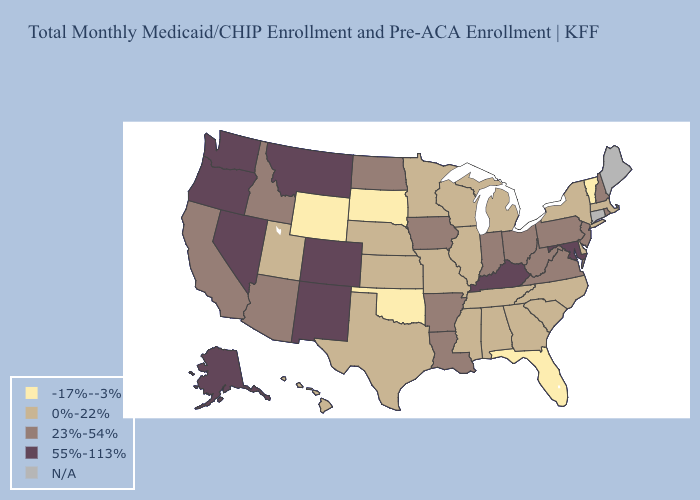Which states hav the highest value in the Northeast?
Give a very brief answer. New Hampshire, New Jersey, Pennsylvania, Rhode Island. What is the lowest value in the USA?
Keep it brief. -17%--3%. Which states hav the highest value in the South?
Answer briefly. Kentucky, Maryland. Which states have the lowest value in the MidWest?
Answer briefly. South Dakota. Does Vermont have the lowest value in the Northeast?
Concise answer only. Yes. Which states hav the highest value in the West?
Short answer required. Alaska, Colorado, Montana, Nevada, New Mexico, Oregon, Washington. Which states have the lowest value in the MidWest?
Be succinct. South Dakota. What is the lowest value in the USA?
Give a very brief answer. -17%--3%. Which states have the highest value in the USA?
Quick response, please. Alaska, Colorado, Kentucky, Maryland, Montana, Nevada, New Mexico, Oregon, Washington. Name the states that have a value in the range N/A?
Quick response, please. Connecticut, Maine. What is the lowest value in the USA?
Write a very short answer. -17%--3%. How many symbols are there in the legend?
Answer briefly. 5. Does Minnesota have the highest value in the MidWest?
Quick response, please. No. Does Montana have the highest value in the USA?
Short answer required. Yes. 